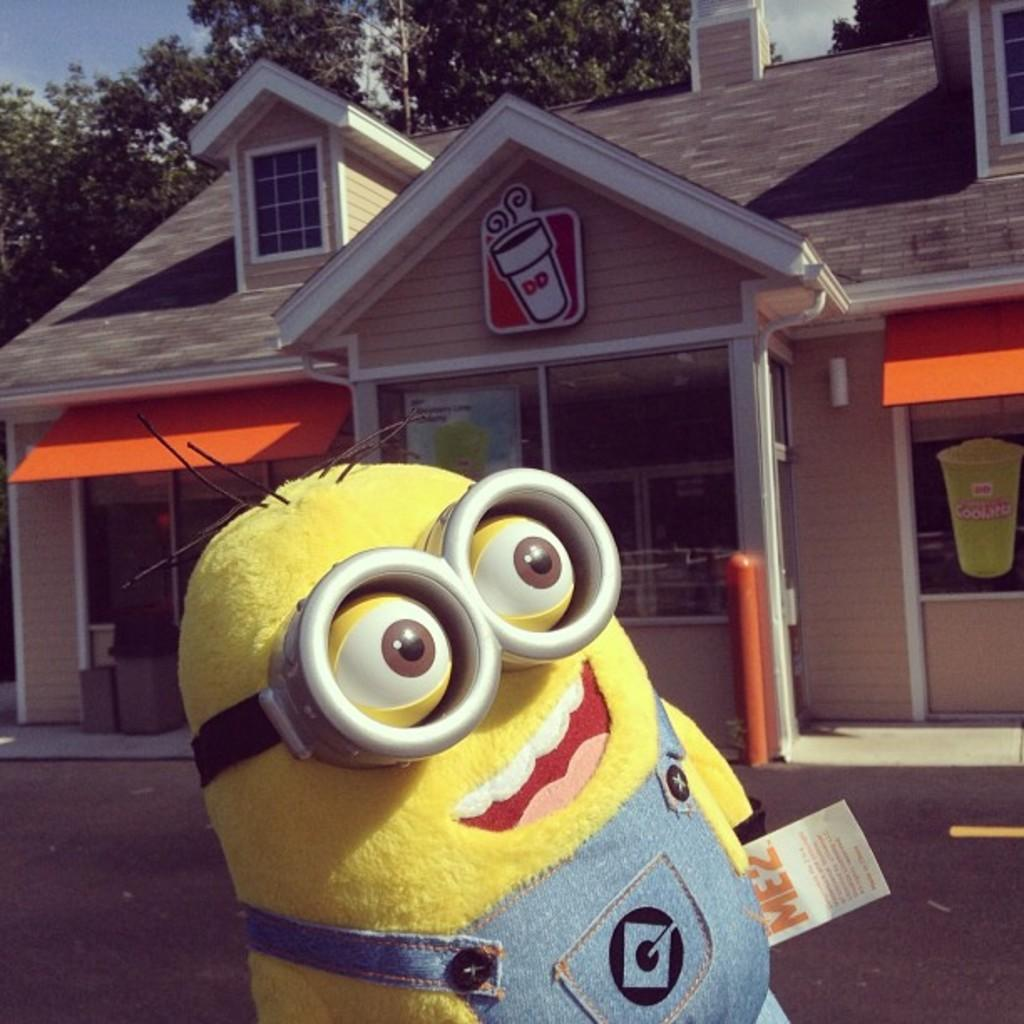What can be seen at the top of the image? The sky with clouds is visible at the top of the image. What type of natural elements are present in the image? There are trees in the image. What type of man-made structures can be seen in the image? There are buildings in the image. What is located at the bottom of the image? A road is present at the bottom of the image. Can you describe a specific object visible at the bottom of the image? A minion soft toy is visible at the bottom of the image. How many mittens are hanging on the trees in the image? There are no mittens present in the image; it features trees, buildings, a road, and a minion soft toy. Can you describe the flying abilities of the minion soft toy in the image? The minion soft toy is not depicted as flying in the image; it is stationary on the ground. 